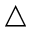Convert formula to latex. <formula><loc_0><loc_0><loc_500><loc_500>\triangle</formula> 